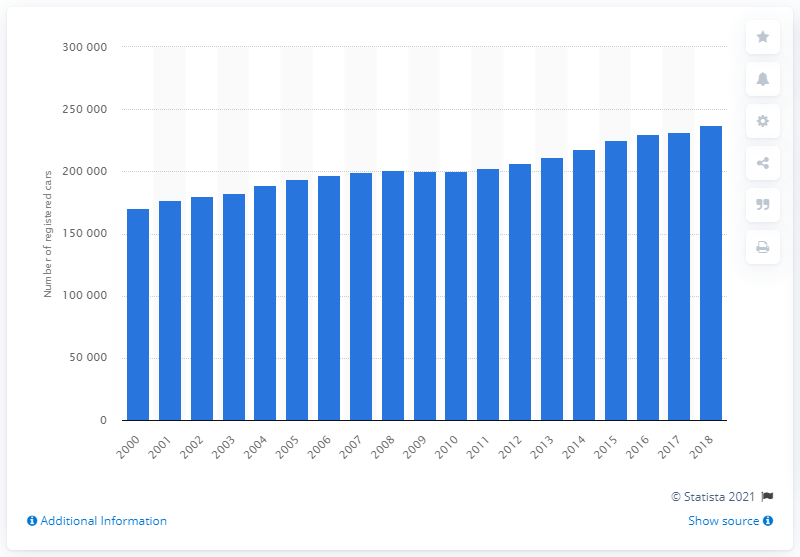How many cars were registered in Great Britain in 2018? While the provided figure of 237,149 seems specific, it is essential to consult the latest governmental databases or statistical resources to obtain an accurate number of car registrations in Great Britain for the year 2018. 